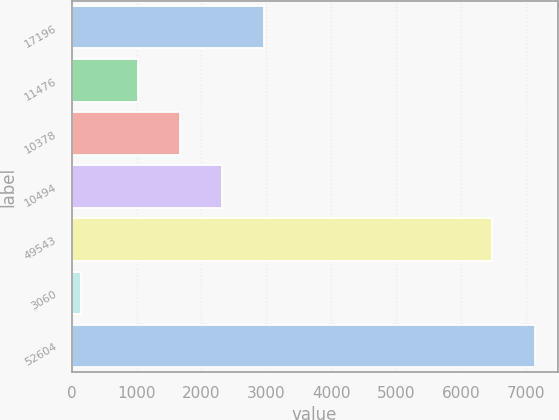<chart> <loc_0><loc_0><loc_500><loc_500><bar_chart><fcel>17196<fcel>11476<fcel>10378<fcel>10494<fcel>49543<fcel>3060<fcel>52604<nl><fcel>2967.17<fcel>1022.9<fcel>1670.99<fcel>2319.08<fcel>6481<fcel>143<fcel>7129.09<nl></chart> 